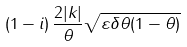<formula> <loc_0><loc_0><loc_500><loc_500>\left ( 1 - i \right ) \frac { 2 | k | } { \theta } \sqrt { \varepsilon \delta \theta ( 1 - \theta ) }</formula> 